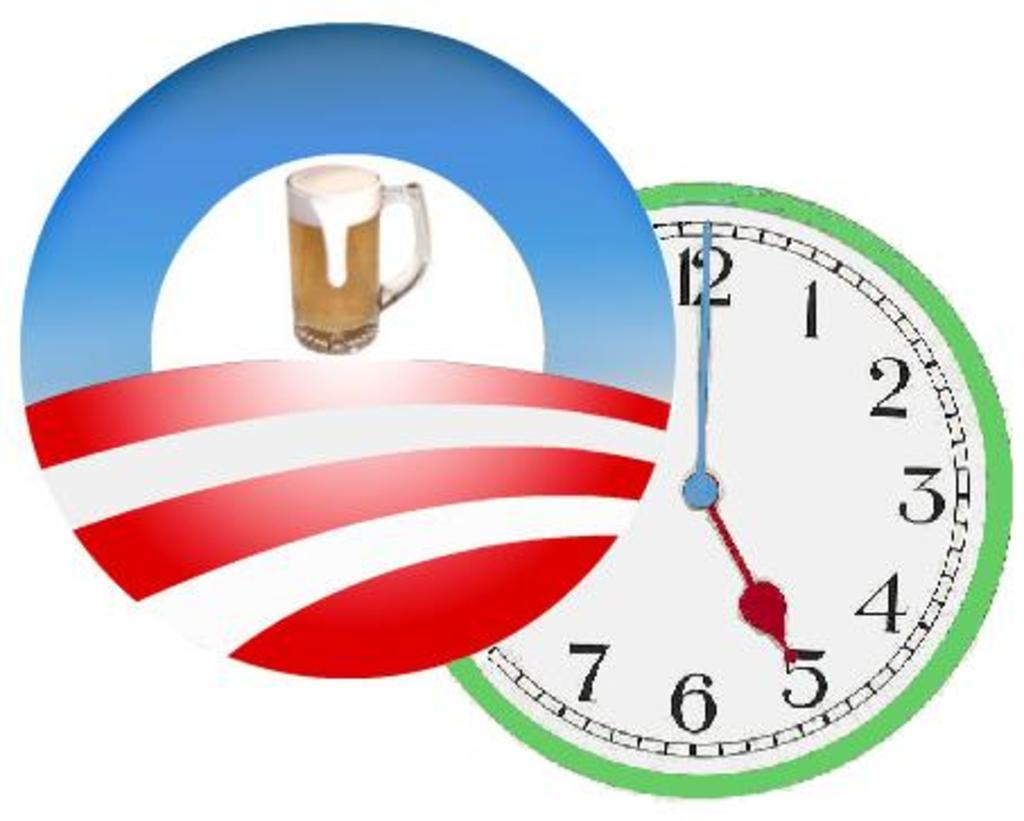Provide a one-sentence caption for the provided image. A simple beer logo states that it's 5:00. 